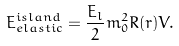Convert formula to latex. <formula><loc_0><loc_0><loc_500><loc_500>E _ { e l a s t i c } ^ { i s l a n d } = \frac { E _ { l } } { 2 } m _ { 0 } ^ { 2 } R ( r ) V .</formula> 